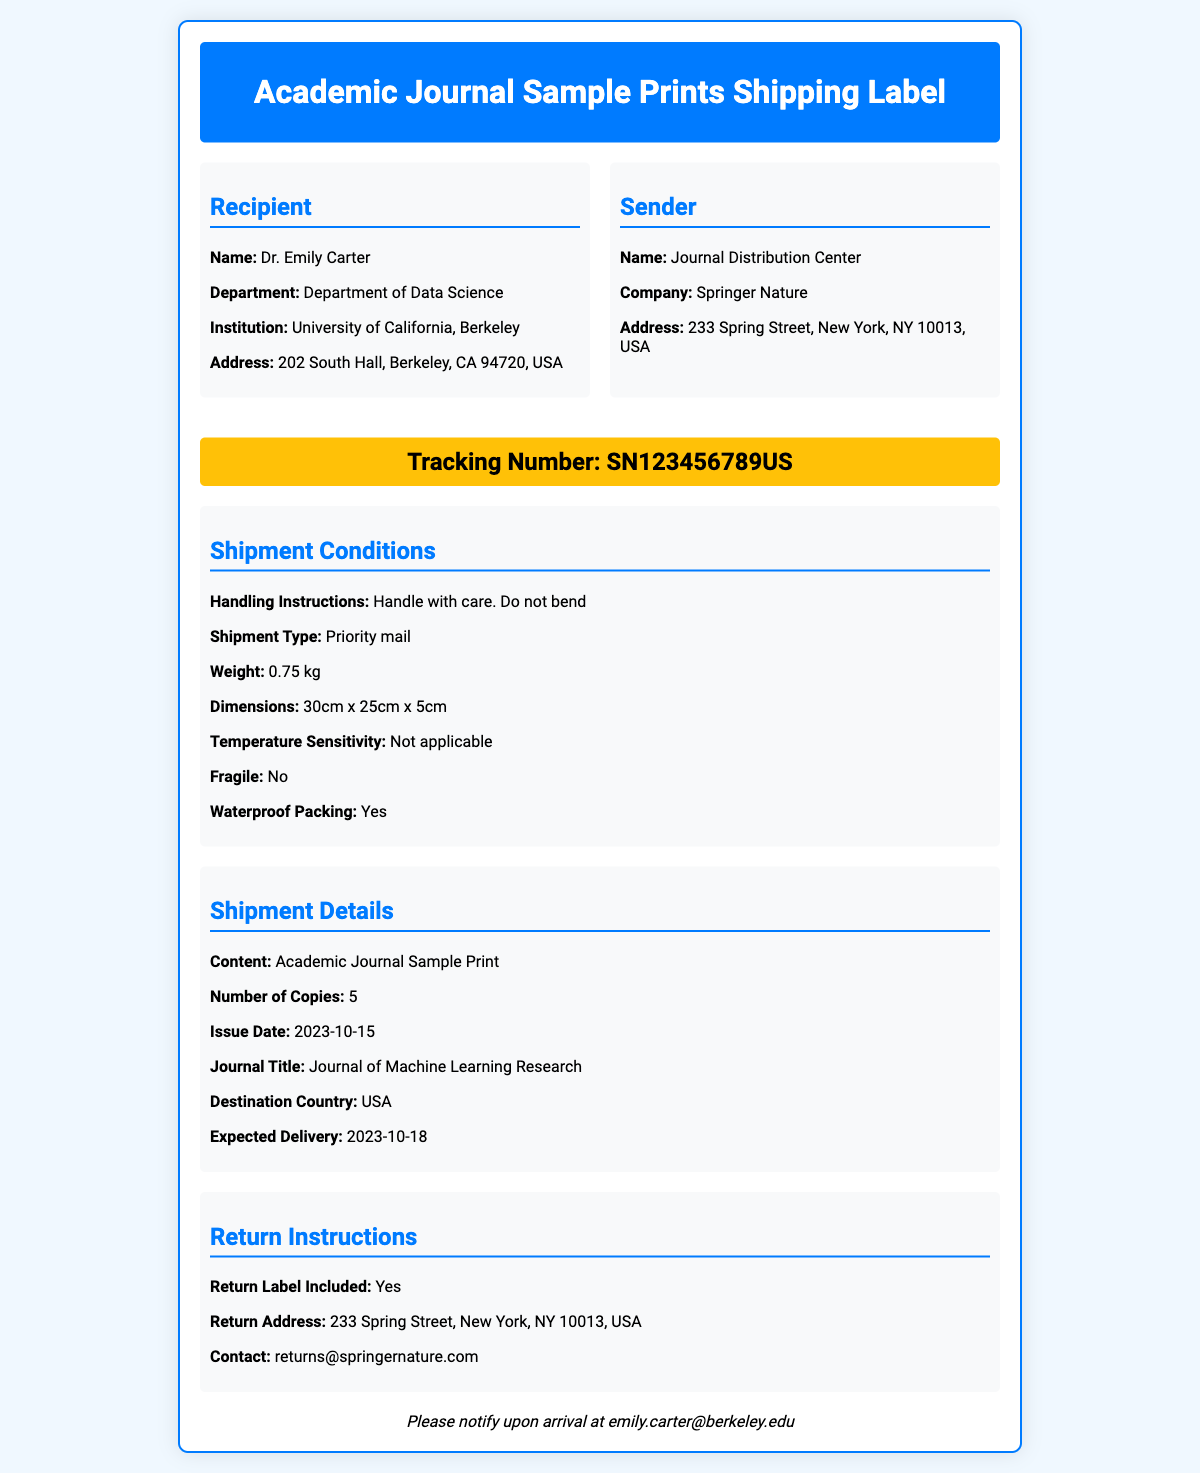What is the recipient's name? The document specifies the recipient's name as Dr. Emily Carter.
Answer: Dr. Emily Carter What is the sender's company? The sender's company is mentioned in the document as Springer Nature.
Answer: Springer Nature What is the tracking number? The shipping label includes the tracking number, which is SN123456789US.
Answer: SN123456789US What is the shipment type? The type of shipment is defined as Priority mail in the document.
Answer: Priority mail What is the expected delivery date? The document states that the expected delivery date is 2023-10-18.
Answer: 2023-10-18 What is the weight of the shipment? The document details the weight of the shipment as 0.75 kg.
Answer: 0.75 kg How many copies of the journal are included? The document indicates that there are 5 copies of the academic journal.
Answer: 5 What are the handling instructions? The document states the handling instructions as "Handle with care. Do not bend."
Answer: Handle with care. Do not bend Is there a return label included? The document confirms that a return label is included with the shipment.
Answer: Yes 